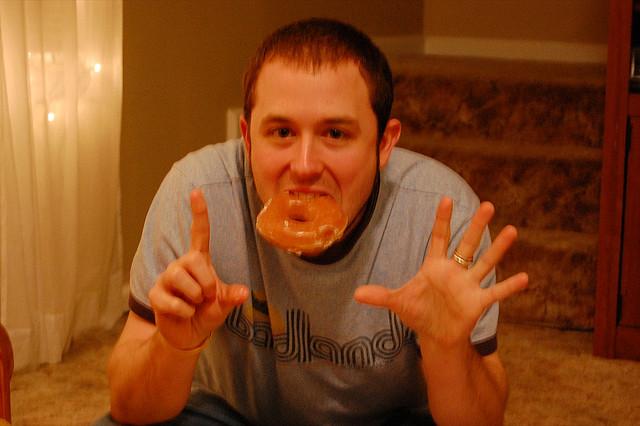Is the man using his hands to eat?
Keep it brief. No. Is this individual in a food eating contest?
Keep it brief. No. What is the man eating?
Give a very brief answer. Donut. 